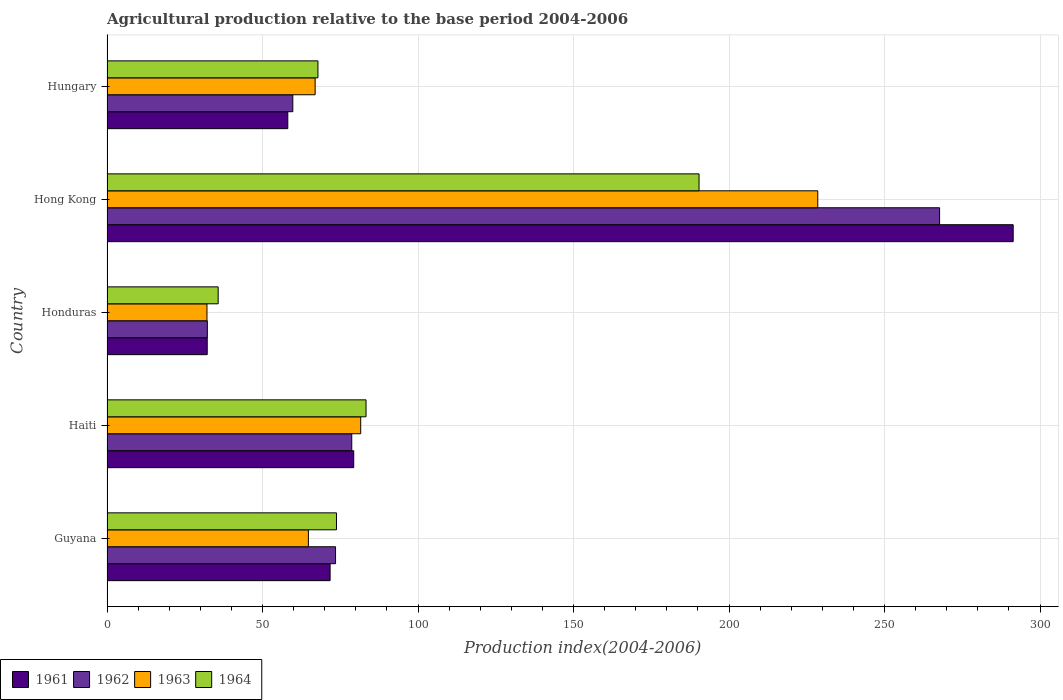How many different coloured bars are there?
Your response must be concise. 4. What is the label of the 2nd group of bars from the top?
Make the answer very short. Hong Kong. What is the agricultural production index in 1963 in Hungary?
Offer a very short reply. 66.92. Across all countries, what is the maximum agricultural production index in 1962?
Your answer should be very brief. 267.69. Across all countries, what is the minimum agricultural production index in 1963?
Make the answer very short. 32.14. In which country was the agricultural production index in 1961 maximum?
Your answer should be compact. Hong Kong. In which country was the agricultural production index in 1963 minimum?
Keep it short and to the point. Honduras. What is the total agricultural production index in 1962 in the graph?
Your answer should be very brief. 511.86. What is the difference between the agricultural production index in 1962 in Guyana and that in Honduras?
Give a very brief answer. 41.22. What is the difference between the agricultural production index in 1961 in Haiti and the agricultural production index in 1963 in Honduras?
Keep it short and to the point. 47.18. What is the average agricultural production index in 1963 per country?
Provide a succinct answer. 94.78. What is the difference between the agricultural production index in 1964 and agricultural production index in 1962 in Haiti?
Ensure brevity in your answer.  4.59. What is the ratio of the agricultural production index in 1962 in Haiti to that in Honduras?
Ensure brevity in your answer.  2.44. Is the agricultural production index in 1964 in Guyana less than that in Hungary?
Your answer should be compact. No. What is the difference between the highest and the second highest agricultural production index in 1961?
Your answer should be compact. 212.03. What is the difference between the highest and the lowest agricultural production index in 1963?
Make the answer very short. 196.38. In how many countries, is the agricultural production index in 1963 greater than the average agricultural production index in 1963 taken over all countries?
Your answer should be very brief. 1. Is the sum of the agricultural production index in 1964 in Haiti and Hong Kong greater than the maximum agricultural production index in 1963 across all countries?
Offer a terse response. Yes. What does the 3rd bar from the top in Guyana represents?
Provide a succinct answer. 1962. What does the 4th bar from the bottom in Honduras represents?
Keep it short and to the point. 1964. Is it the case that in every country, the sum of the agricultural production index in 1964 and agricultural production index in 1963 is greater than the agricultural production index in 1962?
Provide a succinct answer. Yes. How many bars are there?
Give a very brief answer. 20. What is the difference between two consecutive major ticks on the X-axis?
Provide a short and direct response. 50. Are the values on the major ticks of X-axis written in scientific E-notation?
Provide a short and direct response. No. Does the graph contain any zero values?
Provide a short and direct response. No. Where does the legend appear in the graph?
Offer a very short reply. Bottom left. How many legend labels are there?
Offer a terse response. 4. What is the title of the graph?
Provide a short and direct response. Agricultural production relative to the base period 2004-2006. What is the label or title of the X-axis?
Make the answer very short. Production index(2004-2006). What is the Production index(2004-2006) of 1961 in Guyana?
Your response must be concise. 71.73. What is the Production index(2004-2006) of 1962 in Guyana?
Make the answer very short. 73.48. What is the Production index(2004-2006) of 1963 in Guyana?
Offer a terse response. 64.75. What is the Production index(2004-2006) of 1964 in Guyana?
Ensure brevity in your answer.  73.78. What is the Production index(2004-2006) of 1961 in Haiti?
Your answer should be very brief. 79.32. What is the Production index(2004-2006) of 1962 in Haiti?
Your answer should be compact. 78.69. What is the Production index(2004-2006) in 1963 in Haiti?
Offer a very short reply. 81.57. What is the Production index(2004-2006) of 1964 in Haiti?
Ensure brevity in your answer.  83.28. What is the Production index(2004-2006) of 1961 in Honduras?
Your response must be concise. 32.22. What is the Production index(2004-2006) in 1962 in Honduras?
Provide a short and direct response. 32.26. What is the Production index(2004-2006) in 1963 in Honduras?
Your answer should be very brief. 32.14. What is the Production index(2004-2006) of 1964 in Honduras?
Ensure brevity in your answer.  35.74. What is the Production index(2004-2006) of 1961 in Hong Kong?
Your answer should be very brief. 291.35. What is the Production index(2004-2006) in 1962 in Hong Kong?
Your response must be concise. 267.69. What is the Production index(2004-2006) of 1963 in Hong Kong?
Provide a succinct answer. 228.52. What is the Production index(2004-2006) in 1964 in Hong Kong?
Your answer should be very brief. 190.35. What is the Production index(2004-2006) in 1961 in Hungary?
Your response must be concise. 58.13. What is the Production index(2004-2006) in 1962 in Hungary?
Keep it short and to the point. 59.74. What is the Production index(2004-2006) of 1963 in Hungary?
Provide a short and direct response. 66.92. What is the Production index(2004-2006) of 1964 in Hungary?
Keep it short and to the point. 67.82. Across all countries, what is the maximum Production index(2004-2006) in 1961?
Your answer should be compact. 291.35. Across all countries, what is the maximum Production index(2004-2006) in 1962?
Offer a terse response. 267.69. Across all countries, what is the maximum Production index(2004-2006) of 1963?
Your answer should be very brief. 228.52. Across all countries, what is the maximum Production index(2004-2006) of 1964?
Keep it short and to the point. 190.35. Across all countries, what is the minimum Production index(2004-2006) of 1961?
Your answer should be very brief. 32.22. Across all countries, what is the minimum Production index(2004-2006) of 1962?
Keep it short and to the point. 32.26. Across all countries, what is the minimum Production index(2004-2006) of 1963?
Offer a very short reply. 32.14. Across all countries, what is the minimum Production index(2004-2006) in 1964?
Provide a short and direct response. 35.74. What is the total Production index(2004-2006) in 1961 in the graph?
Provide a succinct answer. 532.75. What is the total Production index(2004-2006) in 1962 in the graph?
Offer a very short reply. 511.86. What is the total Production index(2004-2006) of 1963 in the graph?
Keep it short and to the point. 473.9. What is the total Production index(2004-2006) in 1964 in the graph?
Offer a very short reply. 450.97. What is the difference between the Production index(2004-2006) of 1961 in Guyana and that in Haiti?
Keep it short and to the point. -7.59. What is the difference between the Production index(2004-2006) of 1962 in Guyana and that in Haiti?
Offer a very short reply. -5.21. What is the difference between the Production index(2004-2006) of 1963 in Guyana and that in Haiti?
Provide a short and direct response. -16.82. What is the difference between the Production index(2004-2006) in 1964 in Guyana and that in Haiti?
Your response must be concise. -9.5. What is the difference between the Production index(2004-2006) in 1961 in Guyana and that in Honduras?
Your answer should be very brief. 39.51. What is the difference between the Production index(2004-2006) in 1962 in Guyana and that in Honduras?
Your answer should be compact. 41.22. What is the difference between the Production index(2004-2006) in 1963 in Guyana and that in Honduras?
Your response must be concise. 32.61. What is the difference between the Production index(2004-2006) in 1964 in Guyana and that in Honduras?
Provide a short and direct response. 38.04. What is the difference between the Production index(2004-2006) of 1961 in Guyana and that in Hong Kong?
Your answer should be compact. -219.62. What is the difference between the Production index(2004-2006) of 1962 in Guyana and that in Hong Kong?
Keep it short and to the point. -194.21. What is the difference between the Production index(2004-2006) in 1963 in Guyana and that in Hong Kong?
Your answer should be compact. -163.77. What is the difference between the Production index(2004-2006) of 1964 in Guyana and that in Hong Kong?
Offer a very short reply. -116.57. What is the difference between the Production index(2004-2006) of 1961 in Guyana and that in Hungary?
Give a very brief answer. 13.6. What is the difference between the Production index(2004-2006) in 1962 in Guyana and that in Hungary?
Your answer should be very brief. 13.74. What is the difference between the Production index(2004-2006) of 1963 in Guyana and that in Hungary?
Offer a terse response. -2.17. What is the difference between the Production index(2004-2006) of 1964 in Guyana and that in Hungary?
Make the answer very short. 5.96. What is the difference between the Production index(2004-2006) of 1961 in Haiti and that in Honduras?
Your answer should be compact. 47.1. What is the difference between the Production index(2004-2006) of 1962 in Haiti and that in Honduras?
Offer a very short reply. 46.43. What is the difference between the Production index(2004-2006) in 1963 in Haiti and that in Honduras?
Ensure brevity in your answer.  49.43. What is the difference between the Production index(2004-2006) in 1964 in Haiti and that in Honduras?
Ensure brevity in your answer.  47.54. What is the difference between the Production index(2004-2006) of 1961 in Haiti and that in Hong Kong?
Give a very brief answer. -212.03. What is the difference between the Production index(2004-2006) in 1962 in Haiti and that in Hong Kong?
Provide a short and direct response. -189. What is the difference between the Production index(2004-2006) of 1963 in Haiti and that in Hong Kong?
Offer a terse response. -146.95. What is the difference between the Production index(2004-2006) in 1964 in Haiti and that in Hong Kong?
Your answer should be very brief. -107.07. What is the difference between the Production index(2004-2006) of 1961 in Haiti and that in Hungary?
Give a very brief answer. 21.19. What is the difference between the Production index(2004-2006) in 1962 in Haiti and that in Hungary?
Your response must be concise. 18.95. What is the difference between the Production index(2004-2006) of 1963 in Haiti and that in Hungary?
Offer a very short reply. 14.65. What is the difference between the Production index(2004-2006) of 1964 in Haiti and that in Hungary?
Provide a short and direct response. 15.46. What is the difference between the Production index(2004-2006) of 1961 in Honduras and that in Hong Kong?
Your response must be concise. -259.13. What is the difference between the Production index(2004-2006) of 1962 in Honduras and that in Hong Kong?
Provide a short and direct response. -235.43. What is the difference between the Production index(2004-2006) of 1963 in Honduras and that in Hong Kong?
Make the answer very short. -196.38. What is the difference between the Production index(2004-2006) of 1964 in Honduras and that in Hong Kong?
Make the answer very short. -154.61. What is the difference between the Production index(2004-2006) in 1961 in Honduras and that in Hungary?
Offer a very short reply. -25.91. What is the difference between the Production index(2004-2006) of 1962 in Honduras and that in Hungary?
Provide a succinct answer. -27.48. What is the difference between the Production index(2004-2006) in 1963 in Honduras and that in Hungary?
Keep it short and to the point. -34.78. What is the difference between the Production index(2004-2006) of 1964 in Honduras and that in Hungary?
Offer a very short reply. -32.08. What is the difference between the Production index(2004-2006) of 1961 in Hong Kong and that in Hungary?
Provide a short and direct response. 233.22. What is the difference between the Production index(2004-2006) in 1962 in Hong Kong and that in Hungary?
Make the answer very short. 207.95. What is the difference between the Production index(2004-2006) of 1963 in Hong Kong and that in Hungary?
Your answer should be compact. 161.6. What is the difference between the Production index(2004-2006) in 1964 in Hong Kong and that in Hungary?
Make the answer very short. 122.53. What is the difference between the Production index(2004-2006) of 1961 in Guyana and the Production index(2004-2006) of 1962 in Haiti?
Ensure brevity in your answer.  -6.96. What is the difference between the Production index(2004-2006) in 1961 in Guyana and the Production index(2004-2006) in 1963 in Haiti?
Give a very brief answer. -9.84. What is the difference between the Production index(2004-2006) in 1961 in Guyana and the Production index(2004-2006) in 1964 in Haiti?
Keep it short and to the point. -11.55. What is the difference between the Production index(2004-2006) in 1962 in Guyana and the Production index(2004-2006) in 1963 in Haiti?
Offer a terse response. -8.09. What is the difference between the Production index(2004-2006) in 1962 in Guyana and the Production index(2004-2006) in 1964 in Haiti?
Keep it short and to the point. -9.8. What is the difference between the Production index(2004-2006) of 1963 in Guyana and the Production index(2004-2006) of 1964 in Haiti?
Ensure brevity in your answer.  -18.53. What is the difference between the Production index(2004-2006) of 1961 in Guyana and the Production index(2004-2006) of 1962 in Honduras?
Keep it short and to the point. 39.47. What is the difference between the Production index(2004-2006) in 1961 in Guyana and the Production index(2004-2006) in 1963 in Honduras?
Provide a succinct answer. 39.59. What is the difference between the Production index(2004-2006) of 1961 in Guyana and the Production index(2004-2006) of 1964 in Honduras?
Offer a terse response. 35.99. What is the difference between the Production index(2004-2006) of 1962 in Guyana and the Production index(2004-2006) of 1963 in Honduras?
Your response must be concise. 41.34. What is the difference between the Production index(2004-2006) in 1962 in Guyana and the Production index(2004-2006) in 1964 in Honduras?
Keep it short and to the point. 37.74. What is the difference between the Production index(2004-2006) in 1963 in Guyana and the Production index(2004-2006) in 1964 in Honduras?
Offer a terse response. 29.01. What is the difference between the Production index(2004-2006) in 1961 in Guyana and the Production index(2004-2006) in 1962 in Hong Kong?
Your response must be concise. -195.96. What is the difference between the Production index(2004-2006) of 1961 in Guyana and the Production index(2004-2006) of 1963 in Hong Kong?
Ensure brevity in your answer.  -156.79. What is the difference between the Production index(2004-2006) of 1961 in Guyana and the Production index(2004-2006) of 1964 in Hong Kong?
Provide a succinct answer. -118.62. What is the difference between the Production index(2004-2006) of 1962 in Guyana and the Production index(2004-2006) of 1963 in Hong Kong?
Offer a terse response. -155.04. What is the difference between the Production index(2004-2006) in 1962 in Guyana and the Production index(2004-2006) in 1964 in Hong Kong?
Your answer should be compact. -116.87. What is the difference between the Production index(2004-2006) of 1963 in Guyana and the Production index(2004-2006) of 1964 in Hong Kong?
Provide a succinct answer. -125.6. What is the difference between the Production index(2004-2006) of 1961 in Guyana and the Production index(2004-2006) of 1962 in Hungary?
Offer a terse response. 11.99. What is the difference between the Production index(2004-2006) of 1961 in Guyana and the Production index(2004-2006) of 1963 in Hungary?
Your answer should be very brief. 4.81. What is the difference between the Production index(2004-2006) in 1961 in Guyana and the Production index(2004-2006) in 1964 in Hungary?
Provide a succinct answer. 3.91. What is the difference between the Production index(2004-2006) of 1962 in Guyana and the Production index(2004-2006) of 1963 in Hungary?
Your response must be concise. 6.56. What is the difference between the Production index(2004-2006) in 1962 in Guyana and the Production index(2004-2006) in 1964 in Hungary?
Provide a succinct answer. 5.66. What is the difference between the Production index(2004-2006) of 1963 in Guyana and the Production index(2004-2006) of 1964 in Hungary?
Your answer should be compact. -3.07. What is the difference between the Production index(2004-2006) in 1961 in Haiti and the Production index(2004-2006) in 1962 in Honduras?
Provide a succinct answer. 47.06. What is the difference between the Production index(2004-2006) of 1961 in Haiti and the Production index(2004-2006) of 1963 in Honduras?
Your response must be concise. 47.18. What is the difference between the Production index(2004-2006) of 1961 in Haiti and the Production index(2004-2006) of 1964 in Honduras?
Your answer should be compact. 43.58. What is the difference between the Production index(2004-2006) in 1962 in Haiti and the Production index(2004-2006) in 1963 in Honduras?
Your answer should be compact. 46.55. What is the difference between the Production index(2004-2006) of 1962 in Haiti and the Production index(2004-2006) of 1964 in Honduras?
Your answer should be very brief. 42.95. What is the difference between the Production index(2004-2006) in 1963 in Haiti and the Production index(2004-2006) in 1964 in Honduras?
Keep it short and to the point. 45.83. What is the difference between the Production index(2004-2006) of 1961 in Haiti and the Production index(2004-2006) of 1962 in Hong Kong?
Offer a terse response. -188.37. What is the difference between the Production index(2004-2006) of 1961 in Haiti and the Production index(2004-2006) of 1963 in Hong Kong?
Make the answer very short. -149.2. What is the difference between the Production index(2004-2006) in 1961 in Haiti and the Production index(2004-2006) in 1964 in Hong Kong?
Provide a succinct answer. -111.03. What is the difference between the Production index(2004-2006) in 1962 in Haiti and the Production index(2004-2006) in 1963 in Hong Kong?
Offer a very short reply. -149.83. What is the difference between the Production index(2004-2006) in 1962 in Haiti and the Production index(2004-2006) in 1964 in Hong Kong?
Provide a succinct answer. -111.66. What is the difference between the Production index(2004-2006) of 1963 in Haiti and the Production index(2004-2006) of 1964 in Hong Kong?
Give a very brief answer. -108.78. What is the difference between the Production index(2004-2006) of 1961 in Haiti and the Production index(2004-2006) of 1962 in Hungary?
Keep it short and to the point. 19.58. What is the difference between the Production index(2004-2006) of 1961 in Haiti and the Production index(2004-2006) of 1963 in Hungary?
Provide a short and direct response. 12.4. What is the difference between the Production index(2004-2006) in 1962 in Haiti and the Production index(2004-2006) in 1963 in Hungary?
Provide a succinct answer. 11.77. What is the difference between the Production index(2004-2006) in 1962 in Haiti and the Production index(2004-2006) in 1964 in Hungary?
Give a very brief answer. 10.87. What is the difference between the Production index(2004-2006) of 1963 in Haiti and the Production index(2004-2006) of 1964 in Hungary?
Your answer should be very brief. 13.75. What is the difference between the Production index(2004-2006) of 1961 in Honduras and the Production index(2004-2006) of 1962 in Hong Kong?
Give a very brief answer. -235.47. What is the difference between the Production index(2004-2006) in 1961 in Honduras and the Production index(2004-2006) in 1963 in Hong Kong?
Your answer should be compact. -196.3. What is the difference between the Production index(2004-2006) in 1961 in Honduras and the Production index(2004-2006) in 1964 in Hong Kong?
Offer a terse response. -158.13. What is the difference between the Production index(2004-2006) of 1962 in Honduras and the Production index(2004-2006) of 1963 in Hong Kong?
Provide a succinct answer. -196.26. What is the difference between the Production index(2004-2006) of 1962 in Honduras and the Production index(2004-2006) of 1964 in Hong Kong?
Offer a very short reply. -158.09. What is the difference between the Production index(2004-2006) of 1963 in Honduras and the Production index(2004-2006) of 1964 in Hong Kong?
Provide a succinct answer. -158.21. What is the difference between the Production index(2004-2006) in 1961 in Honduras and the Production index(2004-2006) in 1962 in Hungary?
Ensure brevity in your answer.  -27.52. What is the difference between the Production index(2004-2006) of 1961 in Honduras and the Production index(2004-2006) of 1963 in Hungary?
Give a very brief answer. -34.7. What is the difference between the Production index(2004-2006) of 1961 in Honduras and the Production index(2004-2006) of 1964 in Hungary?
Your answer should be compact. -35.6. What is the difference between the Production index(2004-2006) of 1962 in Honduras and the Production index(2004-2006) of 1963 in Hungary?
Keep it short and to the point. -34.66. What is the difference between the Production index(2004-2006) of 1962 in Honduras and the Production index(2004-2006) of 1964 in Hungary?
Your answer should be compact. -35.56. What is the difference between the Production index(2004-2006) of 1963 in Honduras and the Production index(2004-2006) of 1964 in Hungary?
Offer a very short reply. -35.68. What is the difference between the Production index(2004-2006) in 1961 in Hong Kong and the Production index(2004-2006) in 1962 in Hungary?
Offer a very short reply. 231.61. What is the difference between the Production index(2004-2006) of 1961 in Hong Kong and the Production index(2004-2006) of 1963 in Hungary?
Provide a short and direct response. 224.43. What is the difference between the Production index(2004-2006) in 1961 in Hong Kong and the Production index(2004-2006) in 1964 in Hungary?
Provide a succinct answer. 223.53. What is the difference between the Production index(2004-2006) in 1962 in Hong Kong and the Production index(2004-2006) in 1963 in Hungary?
Provide a succinct answer. 200.77. What is the difference between the Production index(2004-2006) of 1962 in Hong Kong and the Production index(2004-2006) of 1964 in Hungary?
Ensure brevity in your answer.  199.87. What is the difference between the Production index(2004-2006) in 1963 in Hong Kong and the Production index(2004-2006) in 1964 in Hungary?
Provide a succinct answer. 160.7. What is the average Production index(2004-2006) in 1961 per country?
Make the answer very short. 106.55. What is the average Production index(2004-2006) in 1962 per country?
Ensure brevity in your answer.  102.37. What is the average Production index(2004-2006) of 1963 per country?
Make the answer very short. 94.78. What is the average Production index(2004-2006) of 1964 per country?
Provide a succinct answer. 90.19. What is the difference between the Production index(2004-2006) of 1961 and Production index(2004-2006) of 1962 in Guyana?
Keep it short and to the point. -1.75. What is the difference between the Production index(2004-2006) in 1961 and Production index(2004-2006) in 1963 in Guyana?
Give a very brief answer. 6.98. What is the difference between the Production index(2004-2006) of 1961 and Production index(2004-2006) of 1964 in Guyana?
Your response must be concise. -2.05. What is the difference between the Production index(2004-2006) in 1962 and Production index(2004-2006) in 1963 in Guyana?
Offer a terse response. 8.73. What is the difference between the Production index(2004-2006) in 1963 and Production index(2004-2006) in 1964 in Guyana?
Your answer should be compact. -9.03. What is the difference between the Production index(2004-2006) of 1961 and Production index(2004-2006) of 1962 in Haiti?
Provide a succinct answer. 0.63. What is the difference between the Production index(2004-2006) of 1961 and Production index(2004-2006) of 1963 in Haiti?
Ensure brevity in your answer.  -2.25. What is the difference between the Production index(2004-2006) of 1961 and Production index(2004-2006) of 1964 in Haiti?
Provide a short and direct response. -3.96. What is the difference between the Production index(2004-2006) of 1962 and Production index(2004-2006) of 1963 in Haiti?
Your answer should be compact. -2.88. What is the difference between the Production index(2004-2006) of 1962 and Production index(2004-2006) of 1964 in Haiti?
Offer a very short reply. -4.59. What is the difference between the Production index(2004-2006) in 1963 and Production index(2004-2006) in 1964 in Haiti?
Your answer should be compact. -1.71. What is the difference between the Production index(2004-2006) of 1961 and Production index(2004-2006) of 1962 in Honduras?
Provide a short and direct response. -0.04. What is the difference between the Production index(2004-2006) of 1961 and Production index(2004-2006) of 1964 in Honduras?
Offer a very short reply. -3.52. What is the difference between the Production index(2004-2006) of 1962 and Production index(2004-2006) of 1963 in Honduras?
Make the answer very short. 0.12. What is the difference between the Production index(2004-2006) in 1962 and Production index(2004-2006) in 1964 in Honduras?
Your answer should be compact. -3.48. What is the difference between the Production index(2004-2006) of 1963 and Production index(2004-2006) of 1964 in Honduras?
Make the answer very short. -3.6. What is the difference between the Production index(2004-2006) of 1961 and Production index(2004-2006) of 1962 in Hong Kong?
Provide a short and direct response. 23.66. What is the difference between the Production index(2004-2006) in 1961 and Production index(2004-2006) in 1963 in Hong Kong?
Give a very brief answer. 62.83. What is the difference between the Production index(2004-2006) of 1961 and Production index(2004-2006) of 1964 in Hong Kong?
Provide a short and direct response. 101. What is the difference between the Production index(2004-2006) of 1962 and Production index(2004-2006) of 1963 in Hong Kong?
Offer a very short reply. 39.17. What is the difference between the Production index(2004-2006) of 1962 and Production index(2004-2006) of 1964 in Hong Kong?
Your answer should be very brief. 77.34. What is the difference between the Production index(2004-2006) in 1963 and Production index(2004-2006) in 1964 in Hong Kong?
Provide a short and direct response. 38.17. What is the difference between the Production index(2004-2006) in 1961 and Production index(2004-2006) in 1962 in Hungary?
Ensure brevity in your answer.  -1.61. What is the difference between the Production index(2004-2006) of 1961 and Production index(2004-2006) of 1963 in Hungary?
Offer a very short reply. -8.79. What is the difference between the Production index(2004-2006) of 1961 and Production index(2004-2006) of 1964 in Hungary?
Keep it short and to the point. -9.69. What is the difference between the Production index(2004-2006) of 1962 and Production index(2004-2006) of 1963 in Hungary?
Give a very brief answer. -7.18. What is the difference between the Production index(2004-2006) of 1962 and Production index(2004-2006) of 1964 in Hungary?
Your response must be concise. -8.08. What is the difference between the Production index(2004-2006) of 1963 and Production index(2004-2006) of 1964 in Hungary?
Make the answer very short. -0.9. What is the ratio of the Production index(2004-2006) of 1961 in Guyana to that in Haiti?
Provide a succinct answer. 0.9. What is the ratio of the Production index(2004-2006) in 1962 in Guyana to that in Haiti?
Your answer should be very brief. 0.93. What is the ratio of the Production index(2004-2006) of 1963 in Guyana to that in Haiti?
Your response must be concise. 0.79. What is the ratio of the Production index(2004-2006) of 1964 in Guyana to that in Haiti?
Keep it short and to the point. 0.89. What is the ratio of the Production index(2004-2006) of 1961 in Guyana to that in Honduras?
Provide a short and direct response. 2.23. What is the ratio of the Production index(2004-2006) in 1962 in Guyana to that in Honduras?
Provide a succinct answer. 2.28. What is the ratio of the Production index(2004-2006) of 1963 in Guyana to that in Honduras?
Offer a terse response. 2.01. What is the ratio of the Production index(2004-2006) of 1964 in Guyana to that in Honduras?
Ensure brevity in your answer.  2.06. What is the ratio of the Production index(2004-2006) of 1961 in Guyana to that in Hong Kong?
Make the answer very short. 0.25. What is the ratio of the Production index(2004-2006) of 1962 in Guyana to that in Hong Kong?
Your answer should be compact. 0.27. What is the ratio of the Production index(2004-2006) in 1963 in Guyana to that in Hong Kong?
Ensure brevity in your answer.  0.28. What is the ratio of the Production index(2004-2006) of 1964 in Guyana to that in Hong Kong?
Provide a short and direct response. 0.39. What is the ratio of the Production index(2004-2006) in 1961 in Guyana to that in Hungary?
Keep it short and to the point. 1.23. What is the ratio of the Production index(2004-2006) in 1962 in Guyana to that in Hungary?
Ensure brevity in your answer.  1.23. What is the ratio of the Production index(2004-2006) of 1963 in Guyana to that in Hungary?
Provide a succinct answer. 0.97. What is the ratio of the Production index(2004-2006) of 1964 in Guyana to that in Hungary?
Make the answer very short. 1.09. What is the ratio of the Production index(2004-2006) in 1961 in Haiti to that in Honduras?
Make the answer very short. 2.46. What is the ratio of the Production index(2004-2006) in 1962 in Haiti to that in Honduras?
Offer a very short reply. 2.44. What is the ratio of the Production index(2004-2006) in 1963 in Haiti to that in Honduras?
Your response must be concise. 2.54. What is the ratio of the Production index(2004-2006) in 1964 in Haiti to that in Honduras?
Make the answer very short. 2.33. What is the ratio of the Production index(2004-2006) in 1961 in Haiti to that in Hong Kong?
Offer a very short reply. 0.27. What is the ratio of the Production index(2004-2006) in 1962 in Haiti to that in Hong Kong?
Provide a succinct answer. 0.29. What is the ratio of the Production index(2004-2006) of 1963 in Haiti to that in Hong Kong?
Offer a very short reply. 0.36. What is the ratio of the Production index(2004-2006) in 1964 in Haiti to that in Hong Kong?
Offer a very short reply. 0.44. What is the ratio of the Production index(2004-2006) of 1961 in Haiti to that in Hungary?
Offer a terse response. 1.36. What is the ratio of the Production index(2004-2006) of 1962 in Haiti to that in Hungary?
Your answer should be compact. 1.32. What is the ratio of the Production index(2004-2006) of 1963 in Haiti to that in Hungary?
Make the answer very short. 1.22. What is the ratio of the Production index(2004-2006) in 1964 in Haiti to that in Hungary?
Ensure brevity in your answer.  1.23. What is the ratio of the Production index(2004-2006) in 1961 in Honduras to that in Hong Kong?
Provide a succinct answer. 0.11. What is the ratio of the Production index(2004-2006) of 1962 in Honduras to that in Hong Kong?
Offer a very short reply. 0.12. What is the ratio of the Production index(2004-2006) in 1963 in Honduras to that in Hong Kong?
Provide a short and direct response. 0.14. What is the ratio of the Production index(2004-2006) of 1964 in Honduras to that in Hong Kong?
Offer a very short reply. 0.19. What is the ratio of the Production index(2004-2006) in 1961 in Honduras to that in Hungary?
Keep it short and to the point. 0.55. What is the ratio of the Production index(2004-2006) in 1962 in Honduras to that in Hungary?
Make the answer very short. 0.54. What is the ratio of the Production index(2004-2006) in 1963 in Honduras to that in Hungary?
Your answer should be very brief. 0.48. What is the ratio of the Production index(2004-2006) of 1964 in Honduras to that in Hungary?
Your response must be concise. 0.53. What is the ratio of the Production index(2004-2006) of 1961 in Hong Kong to that in Hungary?
Provide a succinct answer. 5.01. What is the ratio of the Production index(2004-2006) of 1962 in Hong Kong to that in Hungary?
Give a very brief answer. 4.48. What is the ratio of the Production index(2004-2006) in 1963 in Hong Kong to that in Hungary?
Provide a succinct answer. 3.41. What is the ratio of the Production index(2004-2006) in 1964 in Hong Kong to that in Hungary?
Provide a short and direct response. 2.81. What is the difference between the highest and the second highest Production index(2004-2006) in 1961?
Provide a short and direct response. 212.03. What is the difference between the highest and the second highest Production index(2004-2006) of 1962?
Your answer should be compact. 189. What is the difference between the highest and the second highest Production index(2004-2006) in 1963?
Offer a terse response. 146.95. What is the difference between the highest and the second highest Production index(2004-2006) of 1964?
Your answer should be very brief. 107.07. What is the difference between the highest and the lowest Production index(2004-2006) in 1961?
Provide a short and direct response. 259.13. What is the difference between the highest and the lowest Production index(2004-2006) in 1962?
Your response must be concise. 235.43. What is the difference between the highest and the lowest Production index(2004-2006) in 1963?
Offer a very short reply. 196.38. What is the difference between the highest and the lowest Production index(2004-2006) in 1964?
Provide a short and direct response. 154.61. 